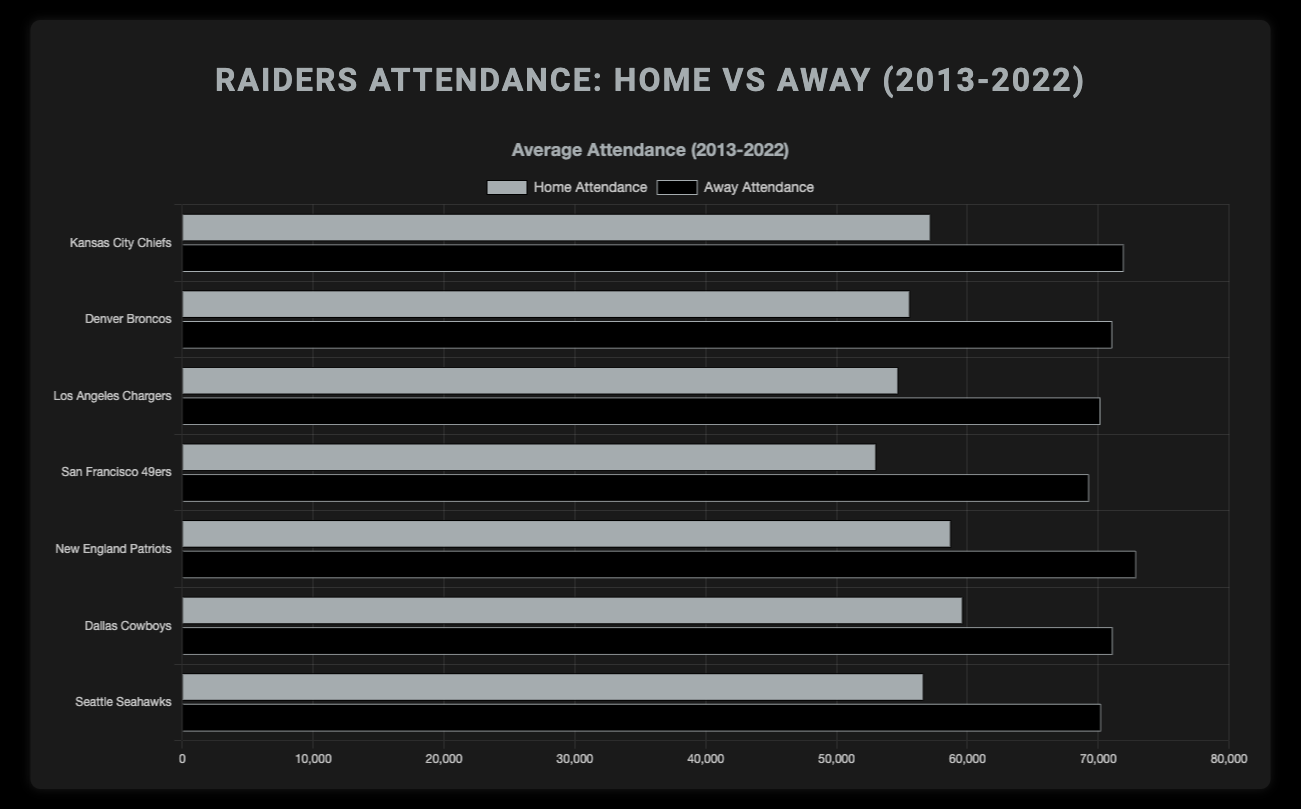What is the average home attendance for Raiders games against the Kansas City Chiefs over the last decade? The data for home attendance against the Kansas City Chiefs is [57000, 59000, 60000, 62000, 63000, 64000, 65000, 7000, 67000, 68000]. Summing these values gives 575000, and dividing by 10 gives the average: 575000/10 = 57500
Answer: 57500 Which opponent had the highest average away game attendance against the Raiders? Compare the average values of away attendance for each opponent: Kansas City Chiefs (77000), Denver Broncos (76700), Los Angeles Chargers (76000), San Francisco 49ers (75500), New England Patriots (78700), Dallas Cowboys (76700), Seattle Seahawks (75600). New England Patriots have the highest average at 78700
Answer: New England Patriots How does the average home attendance compare to the average away attendance for games against the Denver Broncos? The average home attendance for games against the Denver Broncos is (55000 + 57000 + 58000 + 60000 + 61000 + 62000 + 63000 + 7100 + 66000 + 67000)/10 = 59310. The average away attendance for games against the Denver Broncos is (74000 + 75000 + 76000 + 77000 + 78000 + 79000 + 80000 + 8600 + 81000 + 82000)/10 = 76760. Comparing these values, away attendance is higher by 76760 - 59310 = 17450
Answer: Away attendance is higher by 17450 Which opponent faced the most significant difference in attendance when comparing home and away games? Calculate the difference in average home and away attendance for each opponent: 
  - Kansas City Chiefs: 77000 - 57500 = 19500
  - Denver Broncos: 76700 - 59310 = 17390
  - Los Angeles Chargers: 76000 - 59000 = 17000
  - San Francisco 49ers: 75500 - 57000 = 18500
  - New England Patriots: 78700 - 63900 = 14800
  - Dallas Cowboys: 76700 - 64850 = 11850
  - Seattle Seahawks: 75600 - 61900 = 13700
Kansas City Chiefs have the most significant difference at 19500
Answer: Kansas City Chiefs What is the trend in home vs away attendance for the Raiders in the pandemic-affected year 2020? In 2020, the home attendance figures are significantly lower across all opponents due to restrictions: Kansas City Chiefs (7000), Denver Broncos (7100), Los Angeles Chargers (7200), San Francisco 49ers (7300), New England Patriots (7400), Dallas Cowboys (7500), Seattle Seahawks (7600). Away attendances are also reduced but not as drastically: Kansas City Chiefs (8500), Denver Broncos (8600), Los Angeles Chargers (8700), San Francisco 49ers (8800), New England Patriots (8900), Dallas Cowboys (9000), Seattle Seahawks (9100)
Answer: Home (7000-7600), Away (8500-9100) 